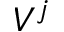Convert formula to latex. <formula><loc_0><loc_0><loc_500><loc_500>V ^ { j }</formula> 